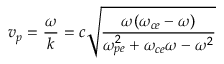Convert formula to latex. <formula><loc_0><loc_0><loc_500><loc_500>v _ { p } = \frac { \omega } { k } = c \sqrt { \frac { \omega ( \omega _ { c e } - \omega ) } { \omega _ { p e } ^ { 2 } + \omega _ { c e } \omega - \omega ^ { 2 } } }</formula> 